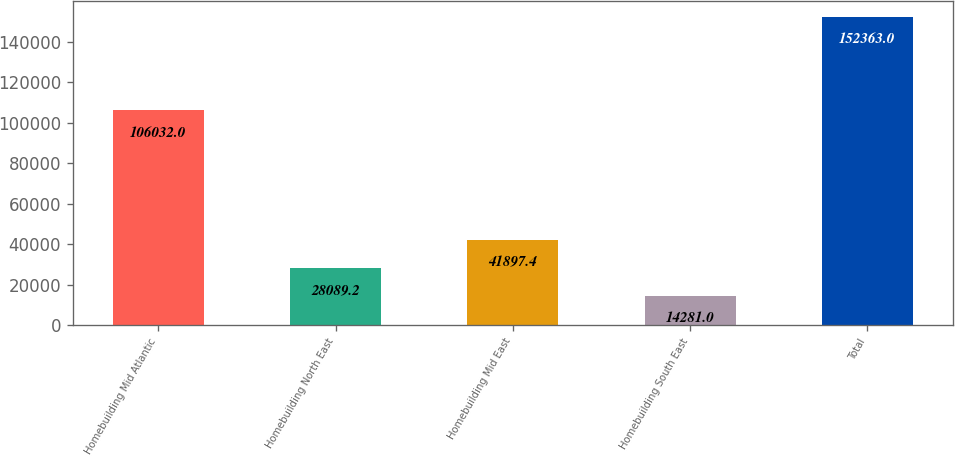Convert chart. <chart><loc_0><loc_0><loc_500><loc_500><bar_chart><fcel>Homebuilding Mid Atlantic<fcel>Homebuilding North East<fcel>Homebuilding Mid East<fcel>Homebuilding South East<fcel>Total<nl><fcel>106032<fcel>28089.2<fcel>41897.4<fcel>14281<fcel>152363<nl></chart> 